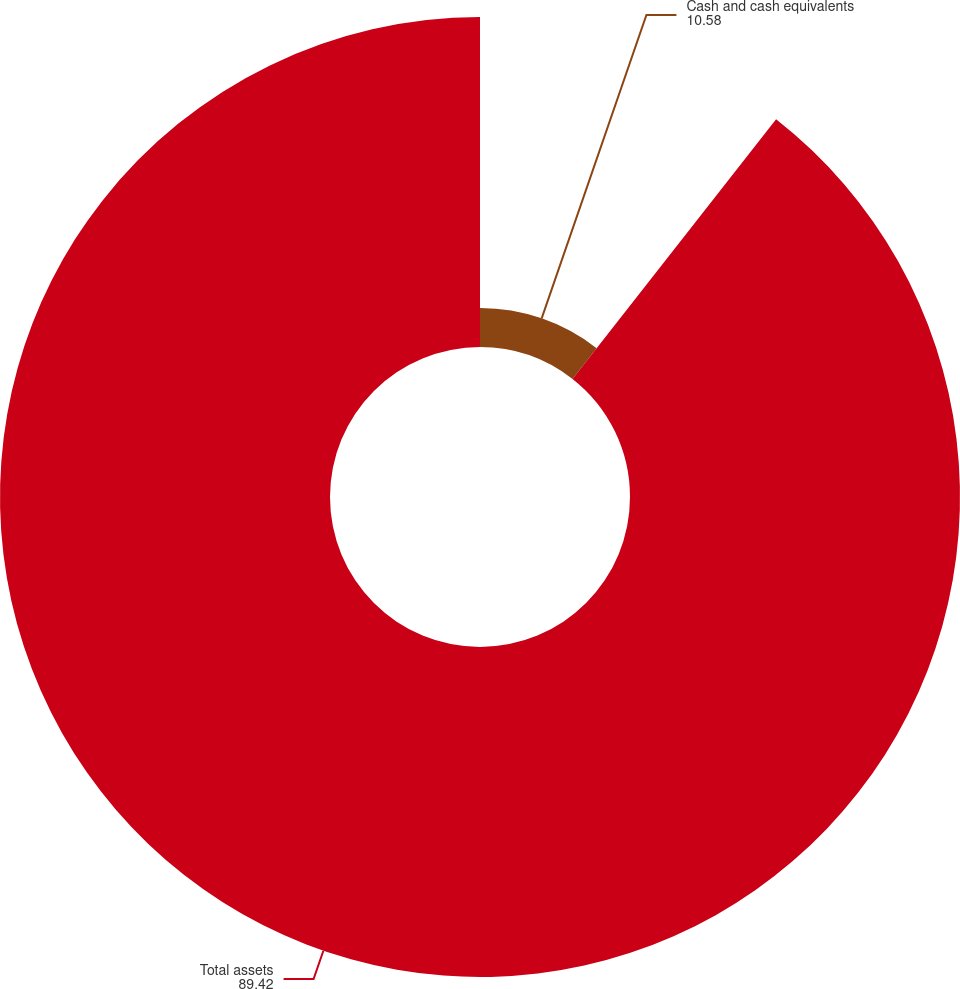<chart> <loc_0><loc_0><loc_500><loc_500><pie_chart><fcel>Cash and cash equivalents<fcel>Total assets<nl><fcel>10.58%<fcel>89.42%<nl></chart> 